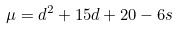Convert formula to latex. <formula><loc_0><loc_0><loc_500><loc_500>\mu = d ^ { 2 } + 1 5 d + 2 0 - 6 s</formula> 